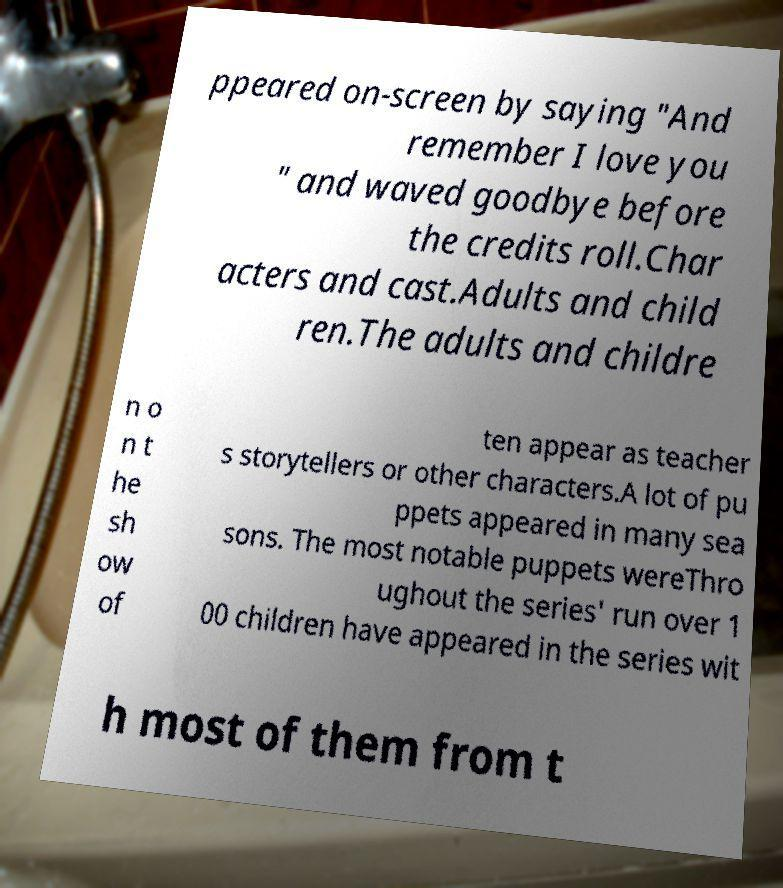What messages or text are displayed in this image? I need them in a readable, typed format. ppeared on-screen by saying "And remember I love you " and waved goodbye before the credits roll.Char acters and cast.Adults and child ren.The adults and childre n o n t he sh ow of ten appear as teacher s storytellers or other characters.A lot of pu ppets appeared in many sea sons. The most notable puppets wereThro ughout the series' run over 1 00 children have appeared in the series wit h most of them from t 